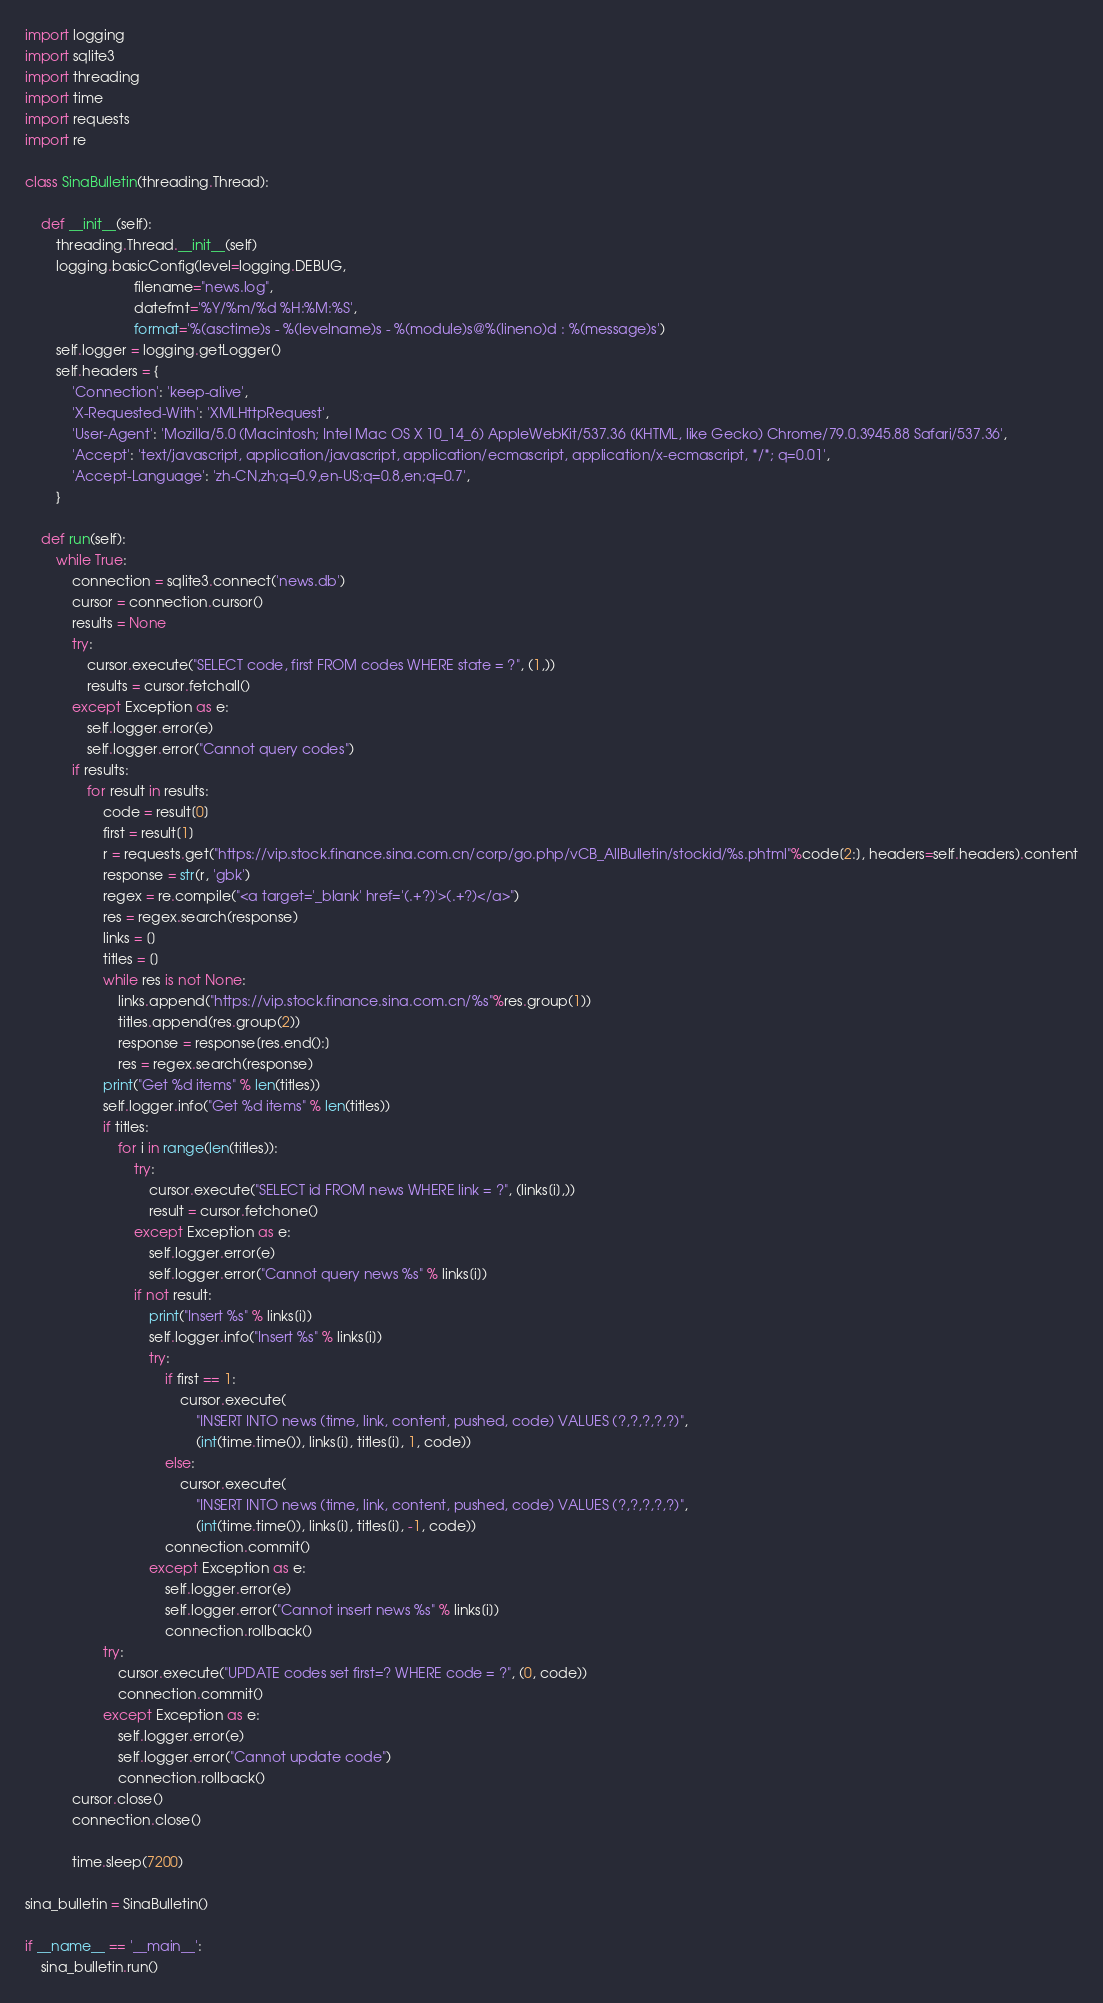<code> <loc_0><loc_0><loc_500><loc_500><_Python_>import logging
import sqlite3
import threading
import time
import requests
import re

class SinaBulletin(threading.Thread):

    def __init__(self):
        threading.Thread.__init__(self)
        logging.basicConfig(level=logging.DEBUG,
                            filename="news.log",
                            datefmt='%Y/%m/%d %H:%M:%S',
                            format='%(asctime)s - %(levelname)s - %(module)s@%(lineno)d : %(message)s')
        self.logger = logging.getLogger()
        self.headers = {
            'Connection': 'keep-alive',
            'X-Requested-With': 'XMLHttpRequest',
            'User-Agent': 'Mozilla/5.0 (Macintosh; Intel Mac OS X 10_14_6) AppleWebKit/537.36 (KHTML, like Gecko) Chrome/79.0.3945.88 Safari/537.36',
            'Accept': 'text/javascript, application/javascript, application/ecmascript, application/x-ecmascript, */*; q=0.01',
            'Accept-Language': 'zh-CN,zh;q=0.9,en-US;q=0.8,en;q=0.7',
        }

    def run(self):
        while True:
            connection = sqlite3.connect('news.db')
            cursor = connection.cursor()
            results = None
            try:
                cursor.execute("SELECT code, first FROM codes WHERE state = ?", (1,))
                results = cursor.fetchall()
            except Exception as e:
                self.logger.error(e)
                self.logger.error("Cannot query codes")
            if results:
                for result in results:
                    code = result[0]
                    first = result[1]
                    r = requests.get("https://vip.stock.finance.sina.com.cn/corp/go.php/vCB_AllBulletin/stockid/%s.phtml"%code[2:], headers=self.headers).content
                    response = str(r, 'gbk')
                    regex = re.compile("<a target='_blank' href='(.+?)'>(.+?)</a>")
                    res = regex.search(response)
                    links = []
                    titles = []
                    while res is not None:
                        links.append("https://vip.stock.finance.sina.com.cn/%s"%res.group(1))
                        titles.append(res.group(2))
                        response = response[res.end():]
                        res = regex.search(response)
                    print("Get %d items" % len(titles))
                    self.logger.info("Get %d items" % len(titles))
                    if titles:
                        for i in range(len(titles)):
                            try:
                                cursor.execute("SELECT id FROM news WHERE link = ?", (links[i],))
                                result = cursor.fetchone()
                            except Exception as e:
                                self.logger.error(e)
                                self.logger.error("Cannot query news %s" % links[i])
                            if not result:
                                print("Insert %s" % links[i])
                                self.logger.info("Insert %s" % links[i])
                                try:
                                    if first == 1:
                                        cursor.execute(
                                            "INSERT INTO news (time, link, content, pushed, code) VALUES (?,?,?,?,?)",
                                            (int(time.time()), links[i], titles[i], 1, code))
                                    else:
                                        cursor.execute(
                                            "INSERT INTO news (time, link, content, pushed, code) VALUES (?,?,?,?,?)",
                                            (int(time.time()), links[i], titles[i], -1, code))
                                    connection.commit()
                                except Exception as e:
                                    self.logger.error(e)
                                    self.logger.error("Cannot insert news %s" % links[i])
                                    connection.rollback()
                    try:
                        cursor.execute("UPDATE codes set first=? WHERE code = ?", (0, code))
                        connection.commit()
                    except Exception as e:
                        self.logger.error(e)
                        self.logger.error("Cannot update code")
                        connection.rollback()
            cursor.close()
            connection.close()

            time.sleep(7200)

sina_bulletin = SinaBulletin()

if __name__ == '__main__':
    sina_bulletin.run()</code> 